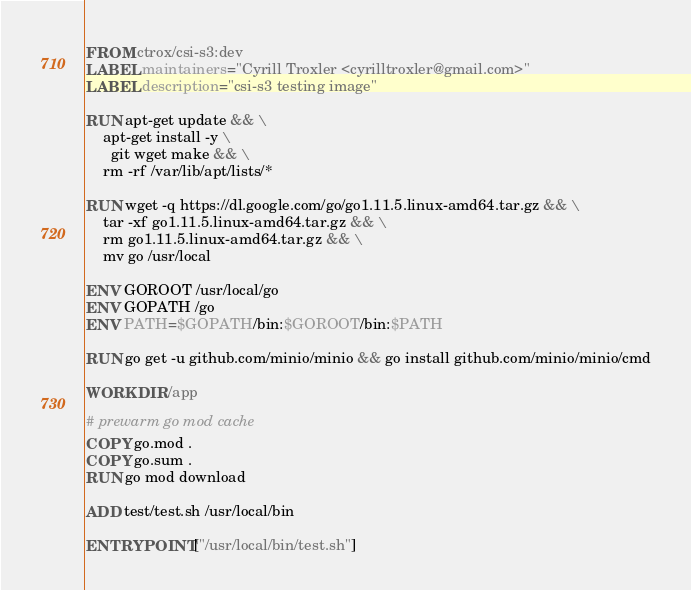<code> <loc_0><loc_0><loc_500><loc_500><_Dockerfile_>FROM ctrox/csi-s3:dev
LABEL maintainers="Cyrill Troxler <cyrilltroxler@gmail.com>"
LABEL description="csi-s3 testing image"

RUN apt-get update && \
    apt-get install -y \
      git wget make && \
    rm -rf /var/lib/apt/lists/*

RUN wget -q https://dl.google.com/go/go1.11.5.linux-amd64.tar.gz && \
    tar -xf go1.11.5.linux-amd64.tar.gz && \
    rm go1.11.5.linux-amd64.tar.gz && \
    mv go /usr/local

ENV GOROOT /usr/local/go
ENV GOPATH /go
ENV PATH=$GOPATH/bin:$GOROOT/bin:$PATH

RUN go get -u github.com/minio/minio && go install github.com/minio/minio/cmd

WORKDIR /app

# prewarm go mod cache
COPY go.mod .
COPY go.sum .
RUN go mod download

ADD test/test.sh /usr/local/bin

ENTRYPOINT ["/usr/local/bin/test.sh"]
</code> 